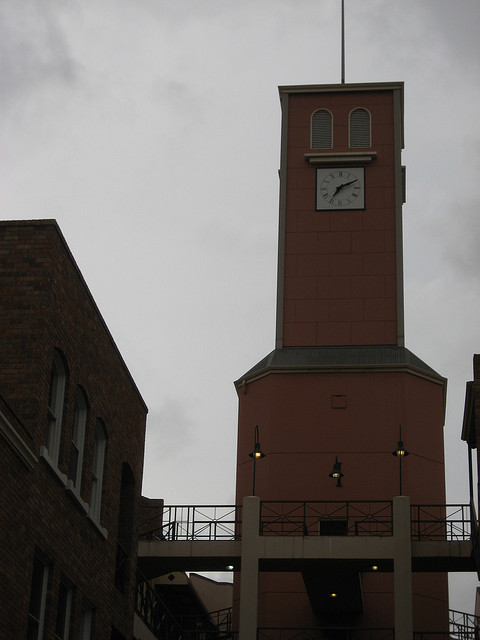<image>What is the place of this structure? I don't know the exact location of this structure. But it could possibly be a clock tower or an office. What is the place of this structure? I don't know the place of this structure. It can be a clock tower, office, church, town bridge tower, or city. 